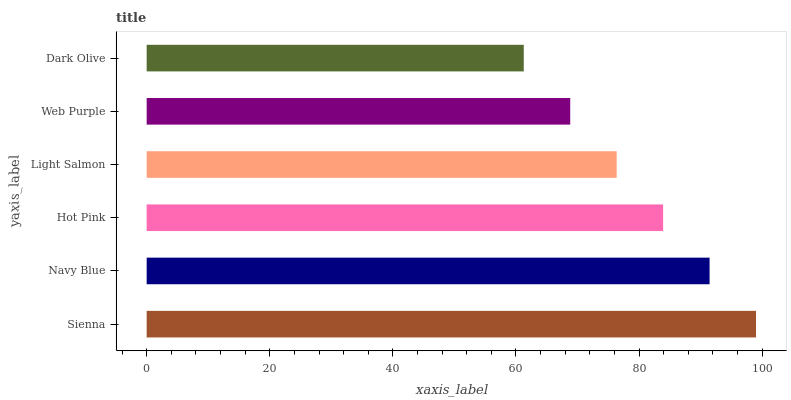Is Dark Olive the minimum?
Answer yes or no. Yes. Is Sienna the maximum?
Answer yes or no. Yes. Is Navy Blue the minimum?
Answer yes or no. No. Is Navy Blue the maximum?
Answer yes or no. No. Is Sienna greater than Navy Blue?
Answer yes or no. Yes. Is Navy Blue less than Sienna?
Answer yes or no. Yes. Is Navy Blue greater than Sienna?
Answer yes or no. No. Is Sienna less than Navy Blue?
Answer yes or no. No. Is Hot Pink the high median?
Answer yes or no. Yes. Is Light Salmon the low median?
Answer yes or no. Yes. Is Navy Blue the high median?
Answer yes or no. No. Is Navy Blue the low median?
Answer yes or no. No. 